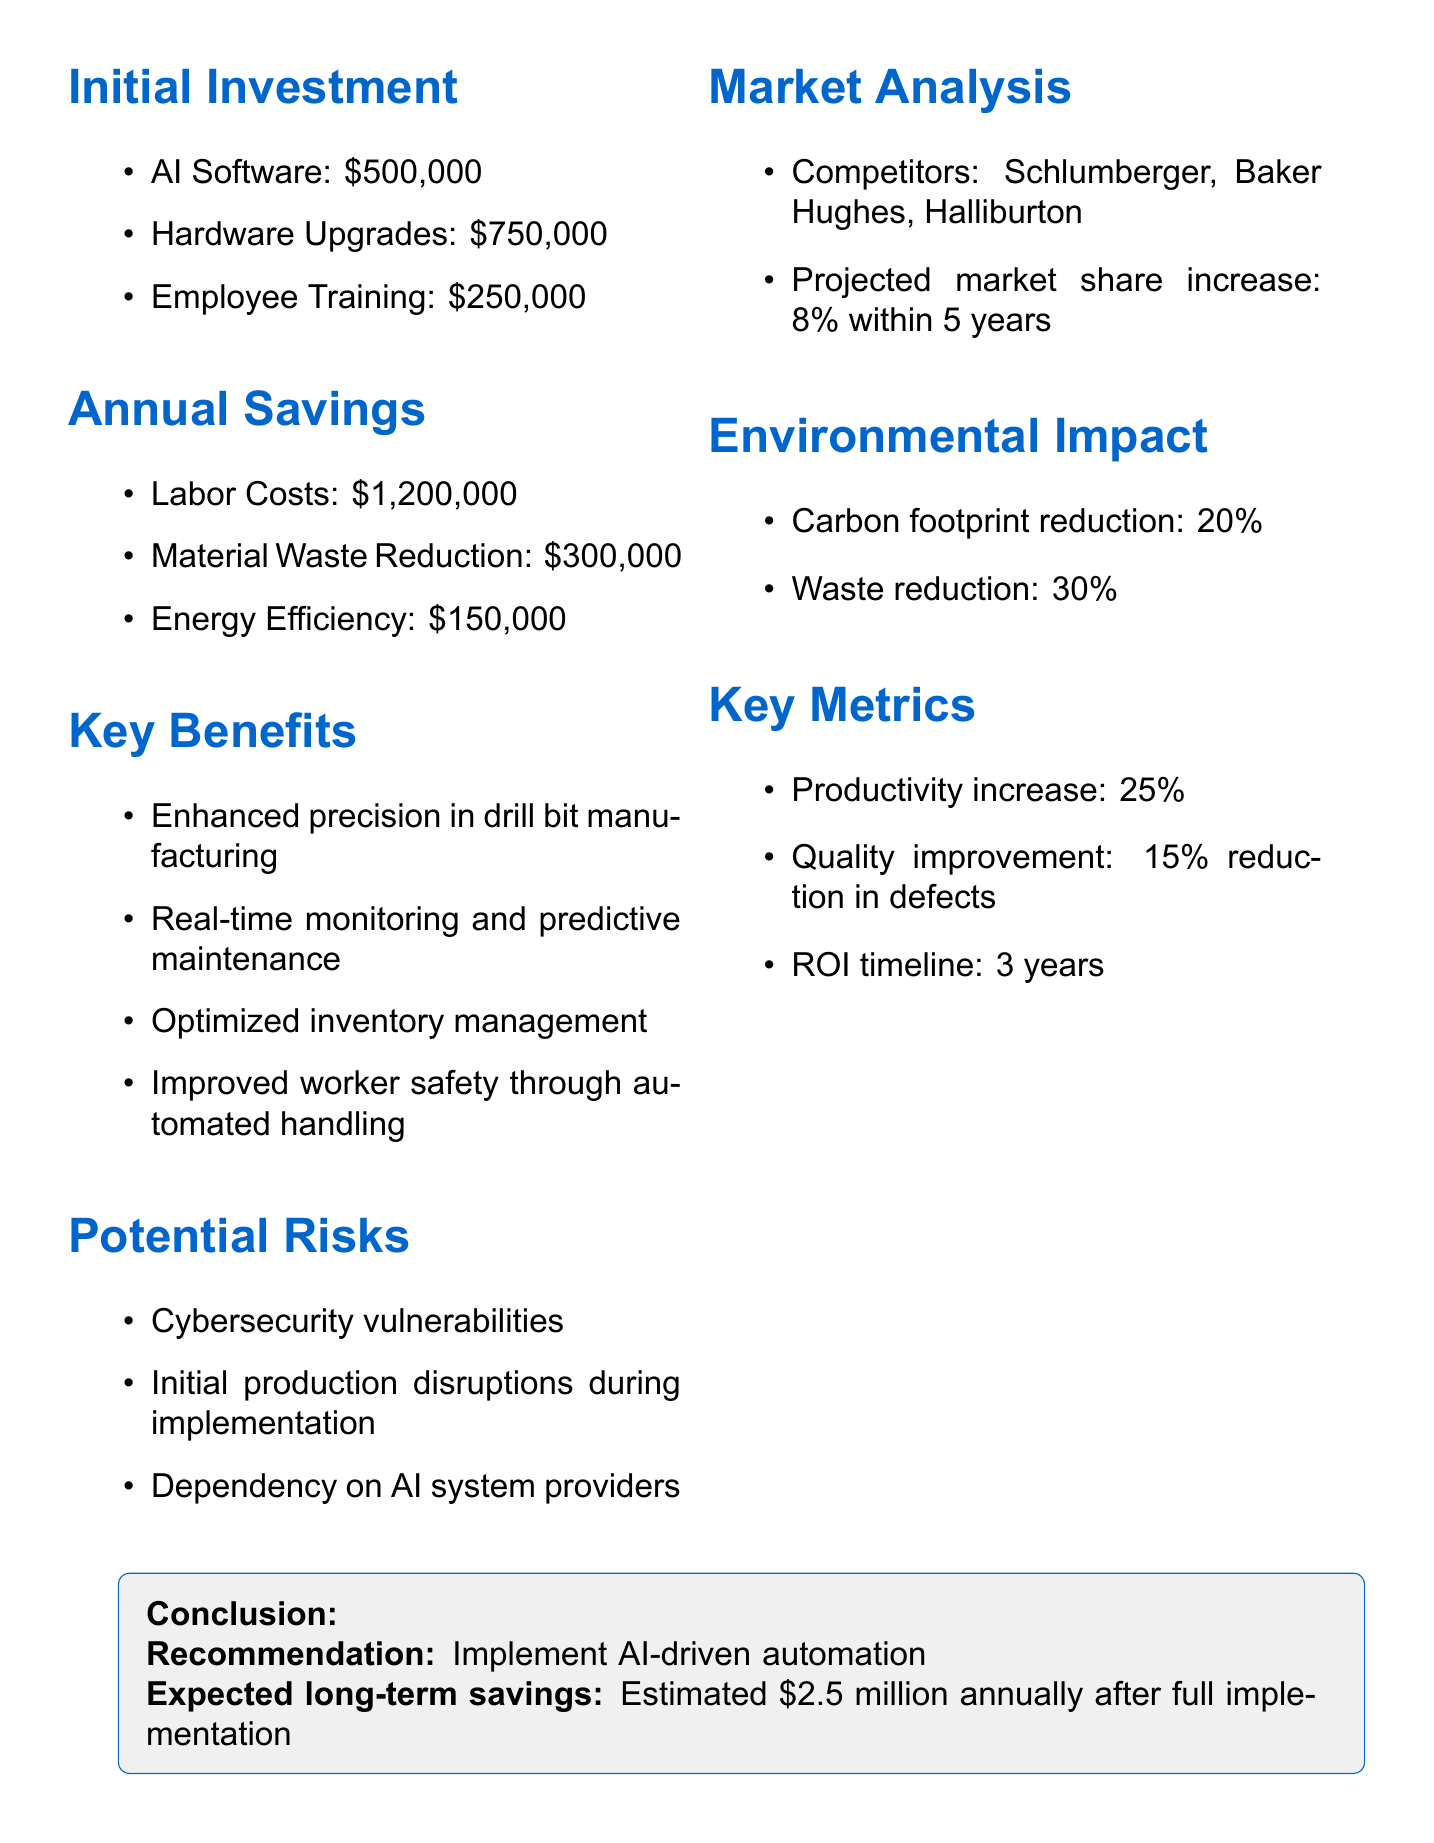What is the initial investment for AI software? The document states the initial investment for AI software is $500,000.
Answer: $500,000 What are the annual savings from labor costs? According to the document, the annual savings from labor costs is $1,200,000.
Answer: $1,200,000 What percentage increase in productivity is projected? The document mentions a projected productivity increase of 25%.
Answer: 25% What is the expected long-term savings after full implementation? The expected long-term savings after full implementation is estimated at $2.5 million annually.
Answer: $2.5 million What is one of the potential risks mentioned? The document lists "Cybersecurity vulnerabilities" as one of the potential risks.
Answer: Cybersecurity vulnerabilities What is the projected market share increase within five years? The document indicates a projected market share increase of 8% within 5 years.
Answer: 8% What is the conclusion regarding AI-driven automation? The document recommends to implement AI-driven automation.
Answer: Implement AI-driven automation How much is the estimated reduction in the carbon footprint? The estimated reduction in the carbon footprint is 20%.
Answer: 20% What is the ROI timeline mentioned in the report? The ROI timeline mentioned is 3 years.
Answer: 3 years 